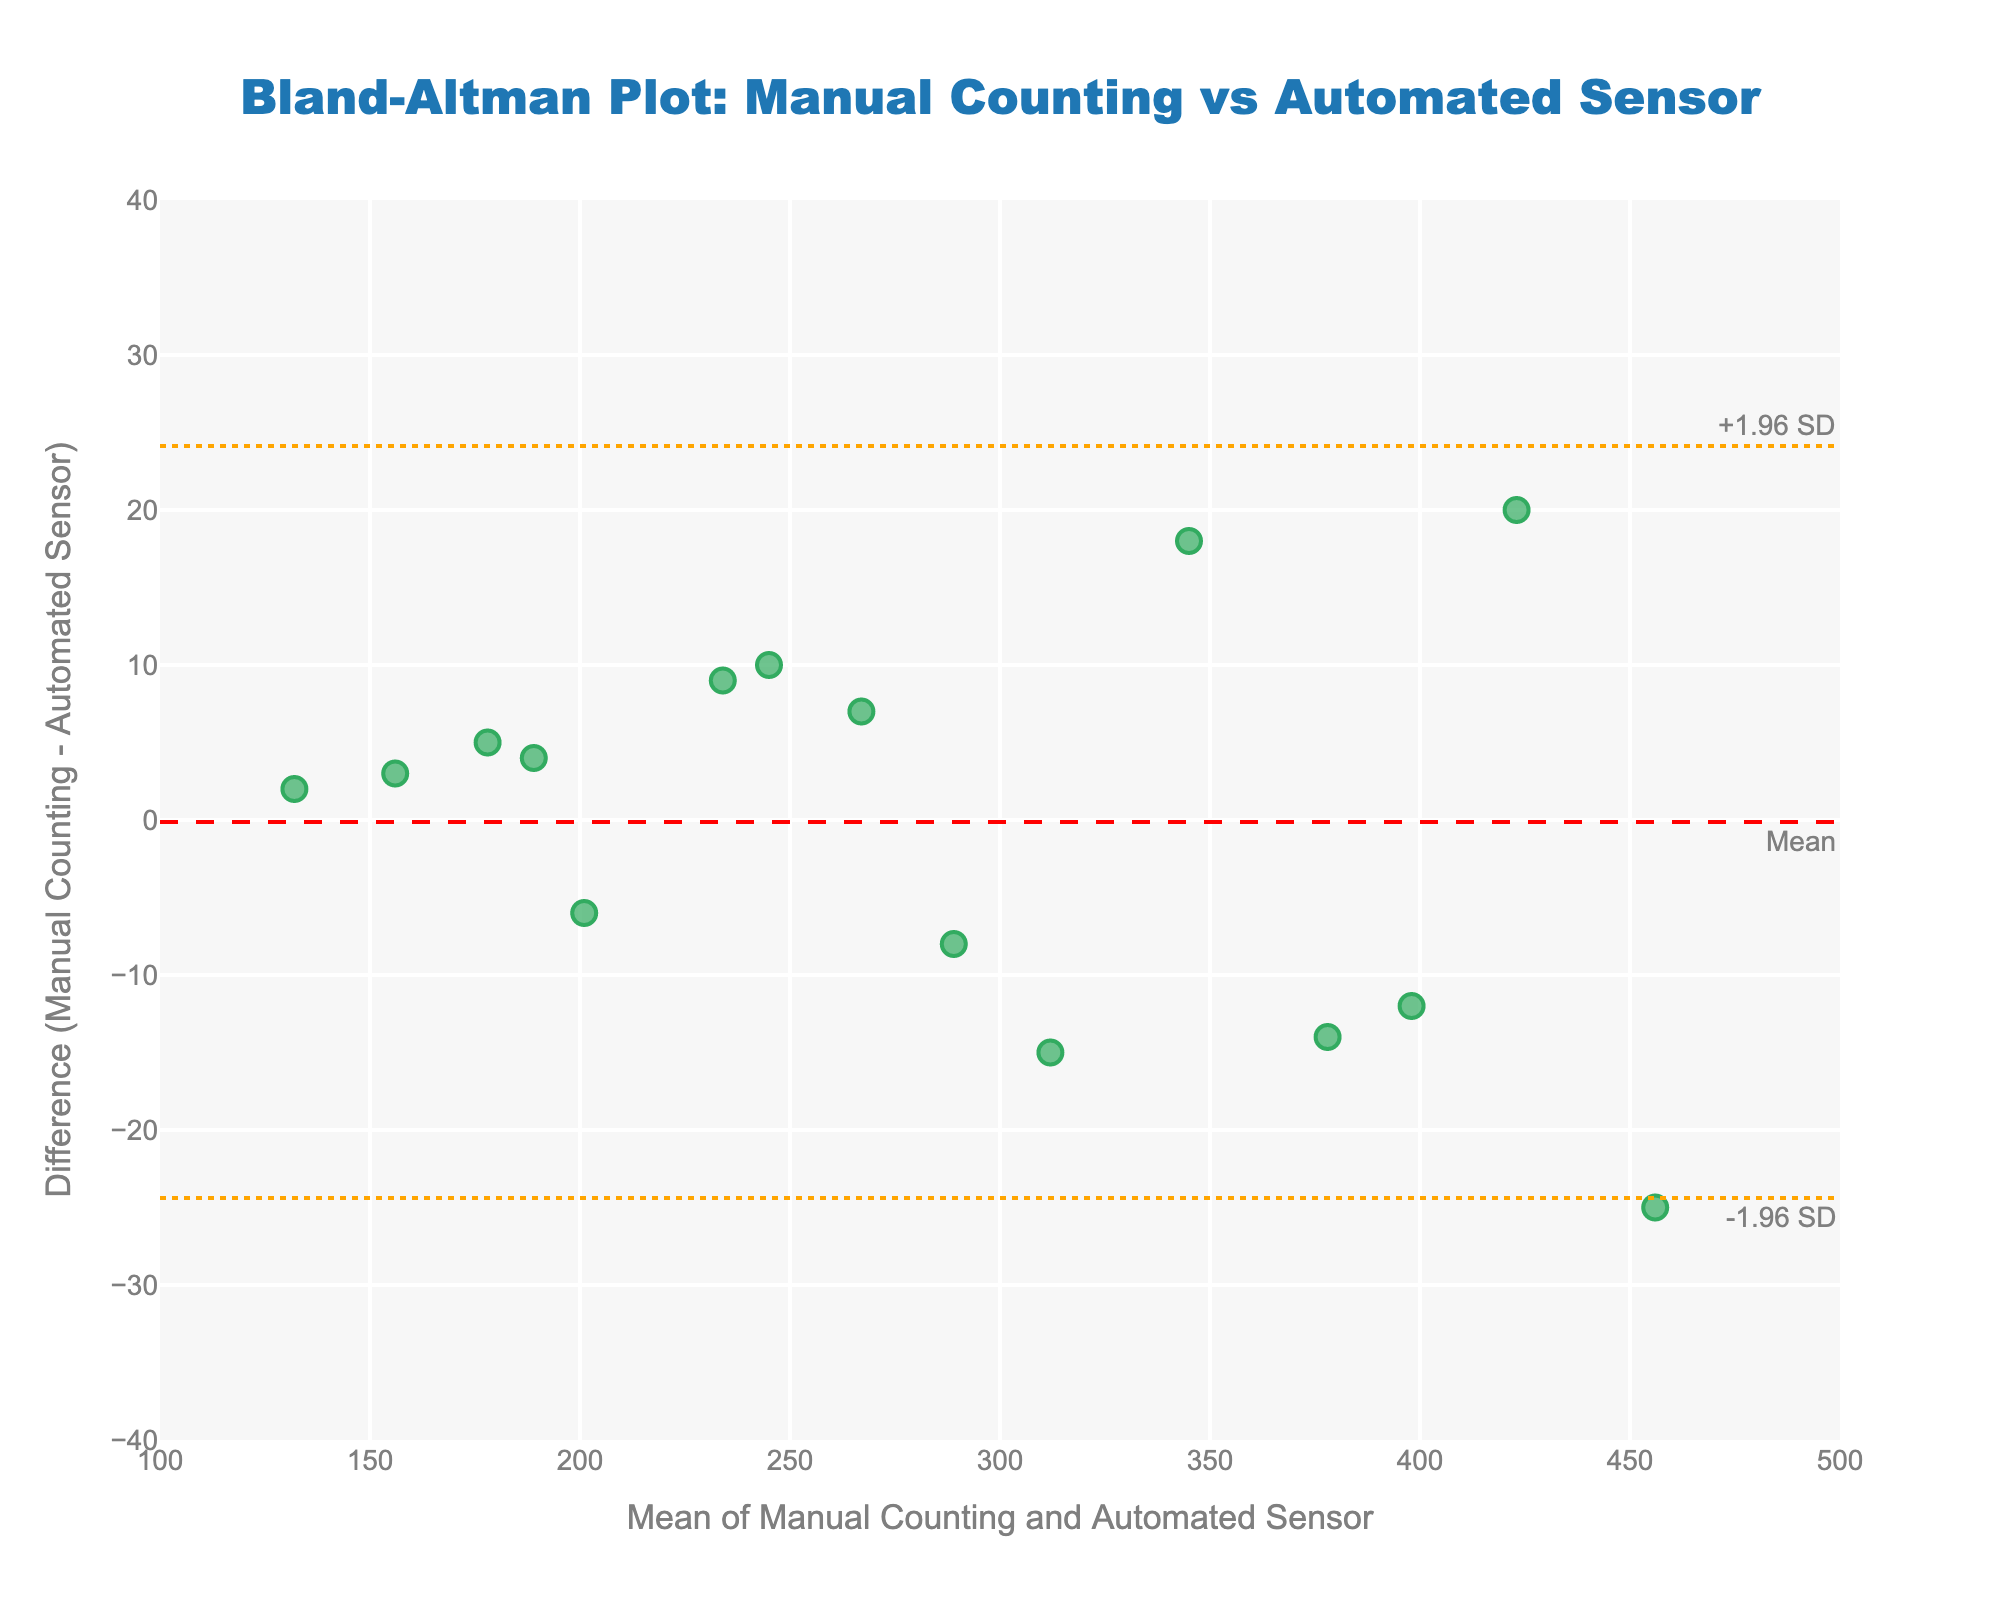How many data points are plotted in this figure? In the figure, each point represents a Mean-Difference pair for the two methods. By counting the points, it is clear that there are 15 data points plotted.
Answer: 15 What is the title of the figure? The title is positioned at the top of the figure. It reads "Bland-Altman Plot: Manual Counting vs Automated Sensor".
Answer: Bland-Altman Plot: Manual Counting vs Automated Sensor Which axis represents the mean of the two passenger counting methods? The x-axis is labeled "Mean of Manual Counting and Automated Sensor", indicating it represents the mean of the two methods.
Answer: x-axis What is the range of the y-axis? The y-axis represents the difference between manual counting and automated sensor. By observing the y-axis scale, the range can be confirmed as from -40 to 40.
Answer: -40 to 40 Which color are the data points in the plot? The color of the data points in the plot is a shade of green.
Answer: Green What is the mean difference between the two methods? The mean difference is shown by a dashed red line on the y-axis. This line is labeled "Mean". The value at the mean line is 0.07.
Answer: 0.07 How many data points fall outside the limits of agreement? By counting the points outside the upper and lower orange dotted lines (+1.96 SD and -1.96 SD), we find that 3 points fall outside these limits.
Answer: 3 What are the values of the upper and lower limits of agreement? The upper limit of agreement is represented by the upper orange dotted line labeled "+1.96 SD" and the lower limit by the lower orange dotted line labeled "-1.96 SD". These values are approximately 23.77 and -23.63, respectively.
Answer: 23.77, -23.63 Which data point has the highest difference between the manual counting and automated sensor values? The highest positive difference can be identified by the point farthest above the mean line. This point corresponds to a mean value of 423 with a difference of 20.
Answer: Mean = 423, Difference = 20 Are there more positive differences or negative differences? By visually inspecting the number of points above and below the mean line, we can determine that there are more negative differences (points below the mean line).
Answer: More negative differences 